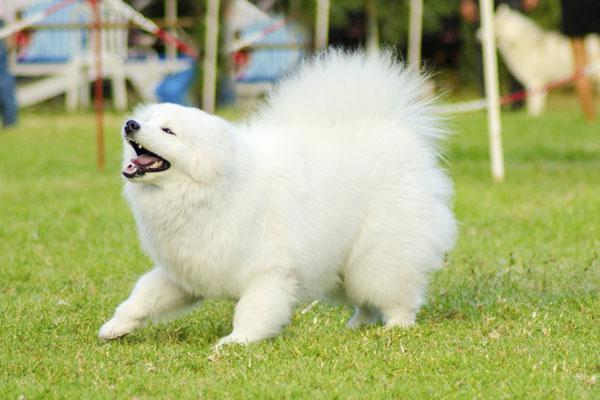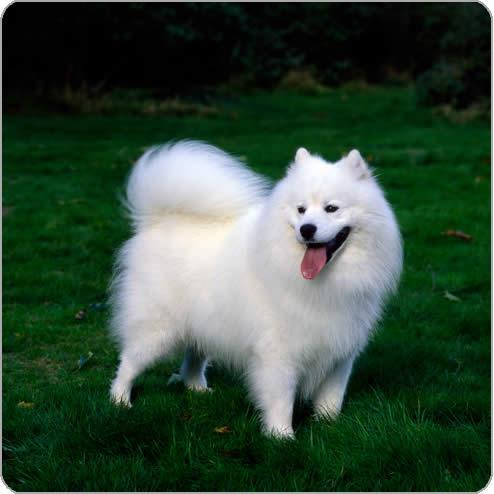The first image is the image on the left, the second image is the image on the right. Assess this claim about the two images: "There are two white dogs standing on the ground outside.". Correct or not? Answer yes or no. Yes. 